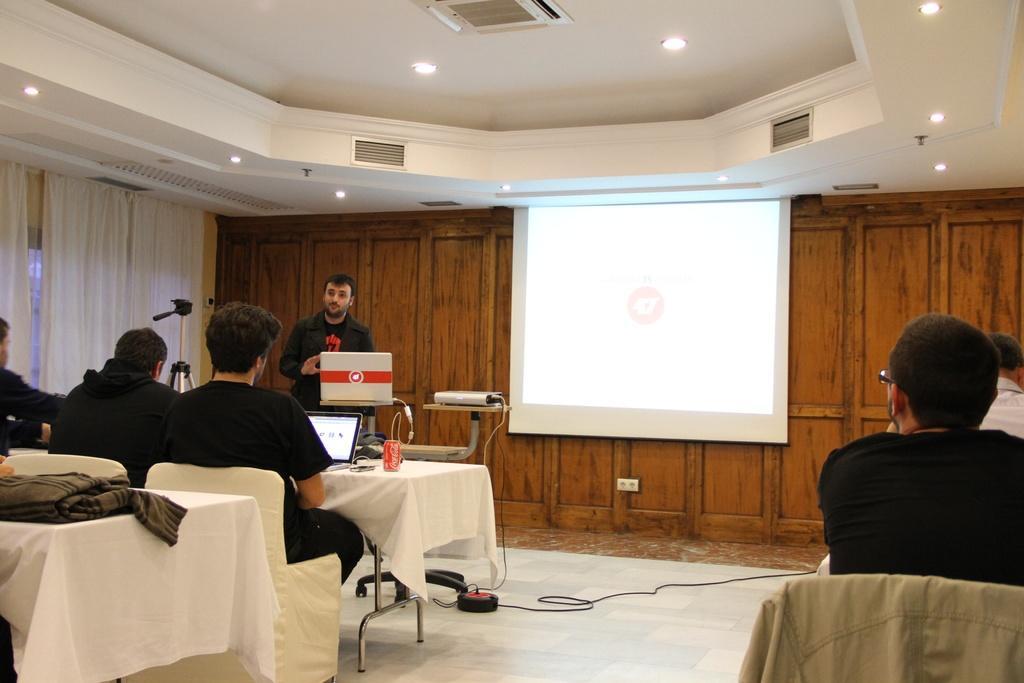Can you describe this image briefly? It seems to be a conference hall with group of people sitting on chair with laptop in front of them looking at the presentation and a guy explaining to everyone and left side of room there is tripod and windows are covered with curtain, on the ceiling there are air vents and lights. 